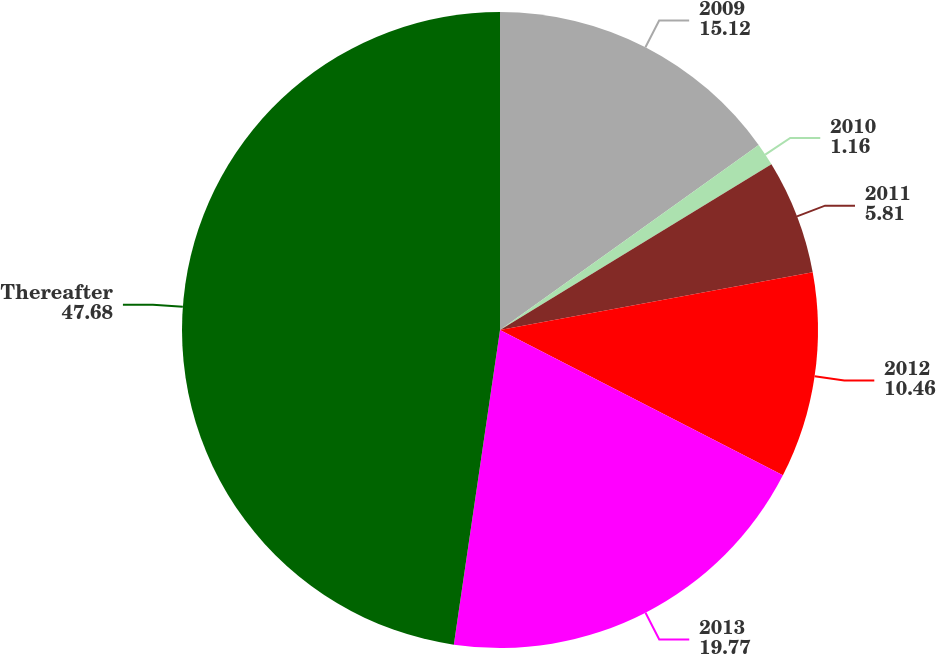Convert chart. <chart><loc_0><loc_0><loc_500><loc_500><pie_chart><fcel>2009<fcel>2010<fcel>2011<fcel>2012<fcel>2013<fcel>Thereafter<nl><fcel>15.12%<fcel>1.16%<fcel>5.81%<fcel>10.46%<fcel>19.77%<fcel>47.68%<nl></chart> 